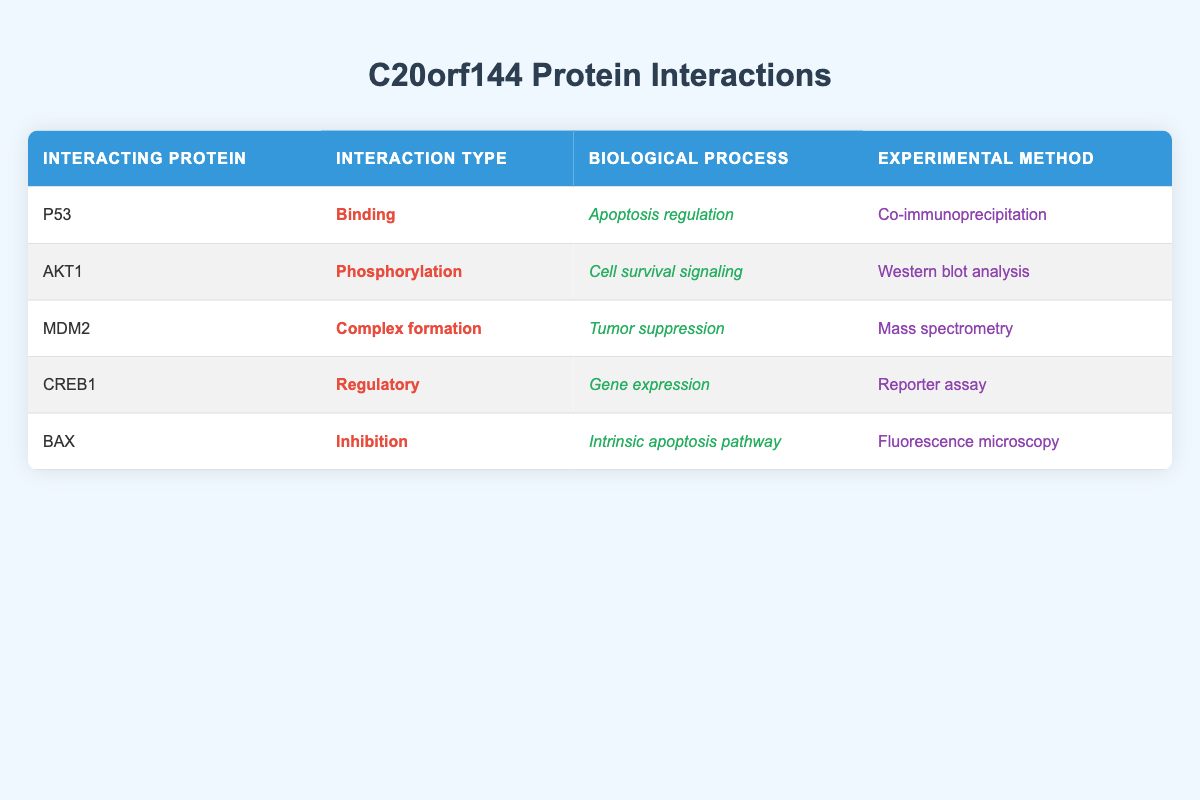What type of interaction does C20orf144 have with P53? The table shows that C20orf144 interacts with P53 through "Binding". This is directly found in the column labeled "Interaction Type" for the row corresponding to P53.
Answer: Binding Which biological process is associated with the interaction between C20orf144 and AKT1? The table indicates that the biological process associated with the interaction between C20orf144 and AKT1 is "Cell survival signaling". This can be found in the "Biological Process" column for AKT1.
Answer: Cell survival signaling How many different experimental methods are used to study C20orf144 interactions? The experimental methods listed are "Co-immunoprecipitation", "Western blot analysis", "Mass spectrometry", "Reporter assay", and "Fluorescence microscopy." There are 5 unique methods used, as identified in the "Experimental Method" column.
Answer: 5 Is the interaction type for BAX an inhibition? Looking at the "Interaction Type" column for the row corresponding to BAX, it states "Inhibition." Thus, the statement is verified as true.
Answer: Yes Which interacting protein is involved in apoptosis regulation and what is the interaction type? The row for P53 indicates that it has a role in "Apoptosis regulation" and the interaction type is "Binding." This information can be found by checking the relevant columns for the P53 row.
Answer: P53, Binding How does the interaction of C20orf144 with MDM2 relate to biological processes? C20orf144 interacts with MDM2 and is associated with "Tumor suppression." This relationship is found under the "Biological Process" column for MDM2, indicating the interaction is involved in this specific process.
Answer: Tumor suppression Are there more protein interactions with phosphorylation than any other interaction type? By counting the interaction types, we see that Phosphorylation (1), Binding (1), Complex formation (1), Regulatory (1), and Inhibition (1) are all represented equally with a total of 5 types. There are therefore not more encounters with phosphorylation.
Answer: No Identify one interaction type associated with CREB1. The table shows that the interaction type associated with CREB1 is "Regulatory," which can be directly found under the "Interaction Type" column for the CREB1 row.
Answer: Regulatory What is the primary biological process linked to C20orf144's interaction with BAX? The interaction with BAX corresponds to the biological process labeled as "Intrinsic apoptosis pathway" in the table. This can be directly gathered from the "Biological Process" column for BAX.
Answer: Intrinsic apoptosis pathway 